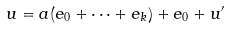<formula> <loc_0><loc_0><loc_500><loc_500>u = a ( e _ { 0 } + \dots + e _ { k } ) + e _ { 0 } + u ^ { \prime }</formula> 